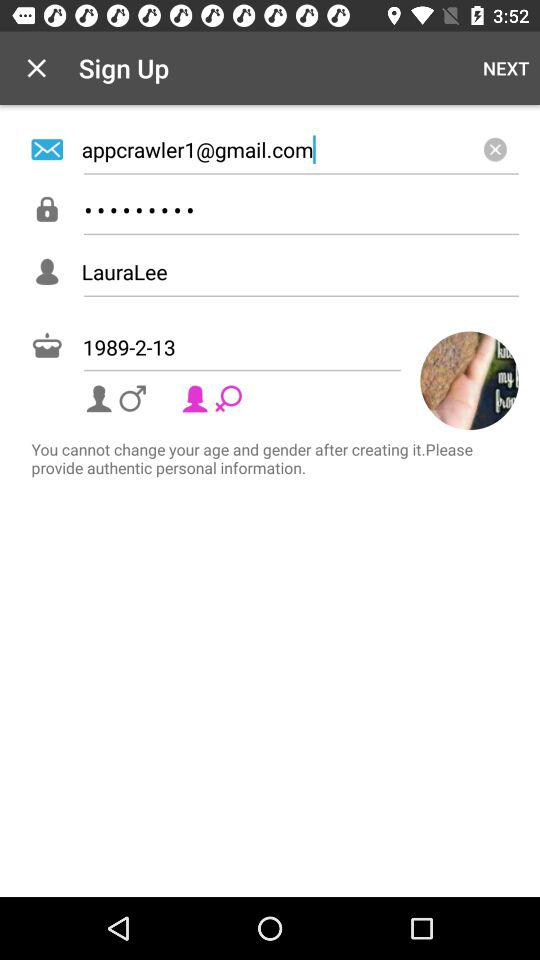Which gender is selected? The selected gender is female. 